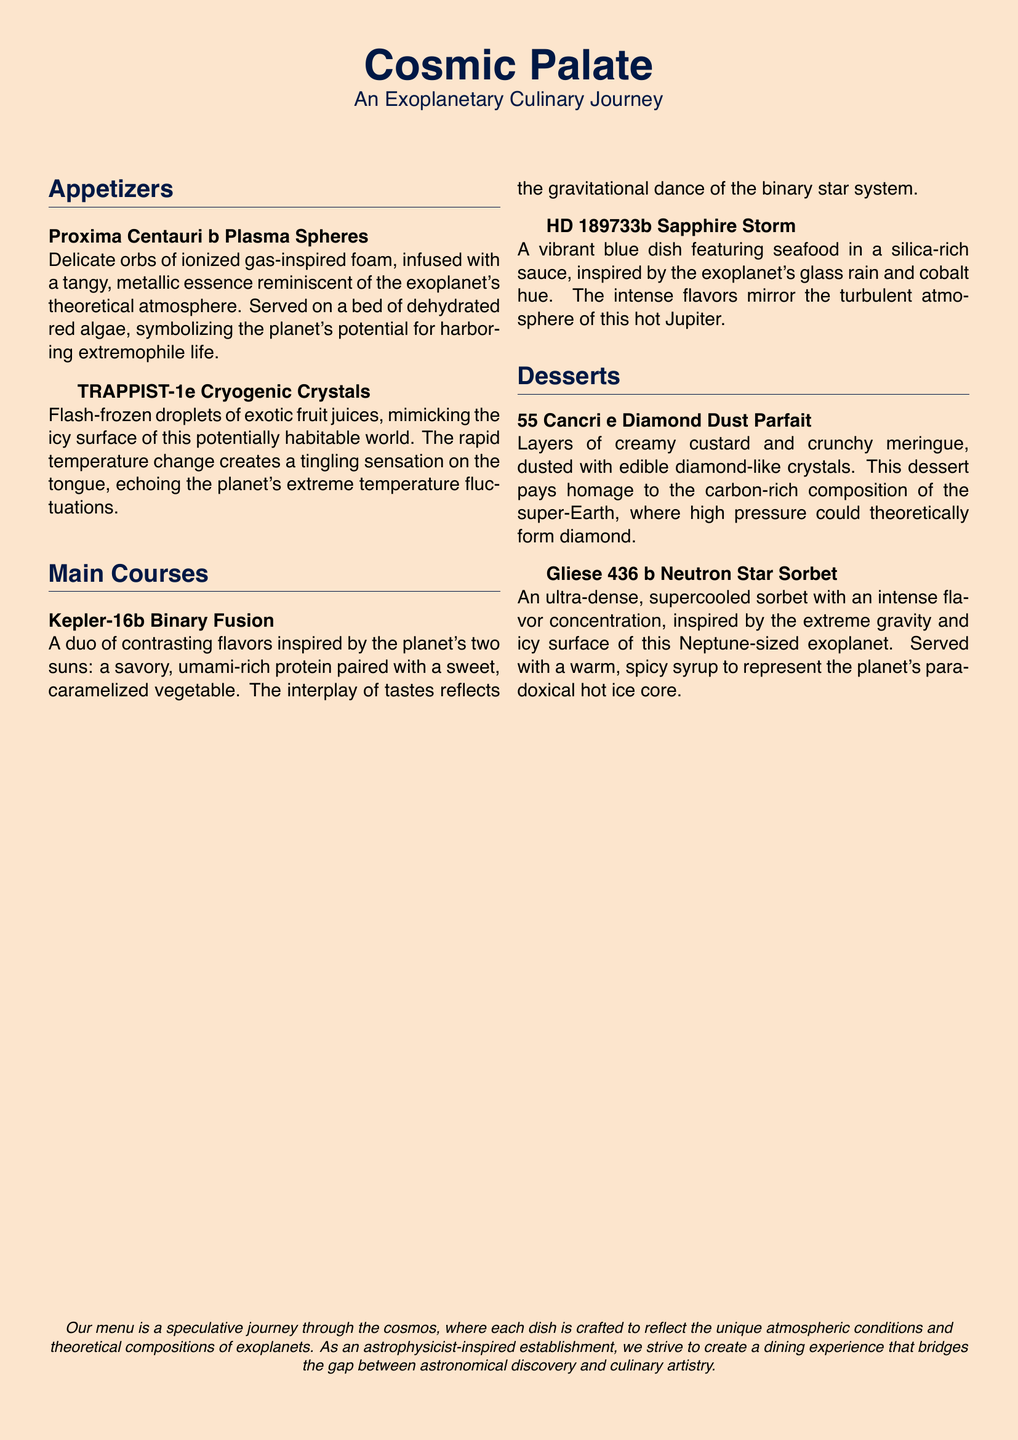What is the name of the first appetizer? The first appetizer listed is "Proxima Centauri b Plasma Spheres."
Answer: Proxima Centauri b Plasma Spheres How many main courses are on the menu? There are two main courses listed in the document.
Answer: Two What dish represents the concept of binary stars? The dish inspired by binary stars is "Kepler-16b Binary Fusion."
Answer: Kepler-16b Binary Fusion What color is the sauce in HD 189733b Sapphire Storm? The sauce in HD 189733b Sapphire Storm is described as silica-rich and vibrant blue.
Answer: Vibrant blue Which dessert has elements resembling diamond? The dessert that has diamond-like elements is "55 Cancri e Diamond Dust Parfait."
Answer: 55 Cancri e Diamond Dust Parfait What is the atmosphere of Gliese 436 b characterized by? Gliese 436 b is characterized by extreme gravity and an icy surface.
Answer: Extreme gravity and icy surface Which dish is associated with ionized gas? The dish associated with ionized gas is "Proxima Centauri b Plasma Spheres."
Answer: Proxima Centauri b Plasma Spheres What type of culinary experience does this menu aim to provide? The menu aims to provide a dining experience that bridges astronomical discovery and culinary artistry.
Answer: A dining experience that bridges astronomical discovery and culinary artistry 